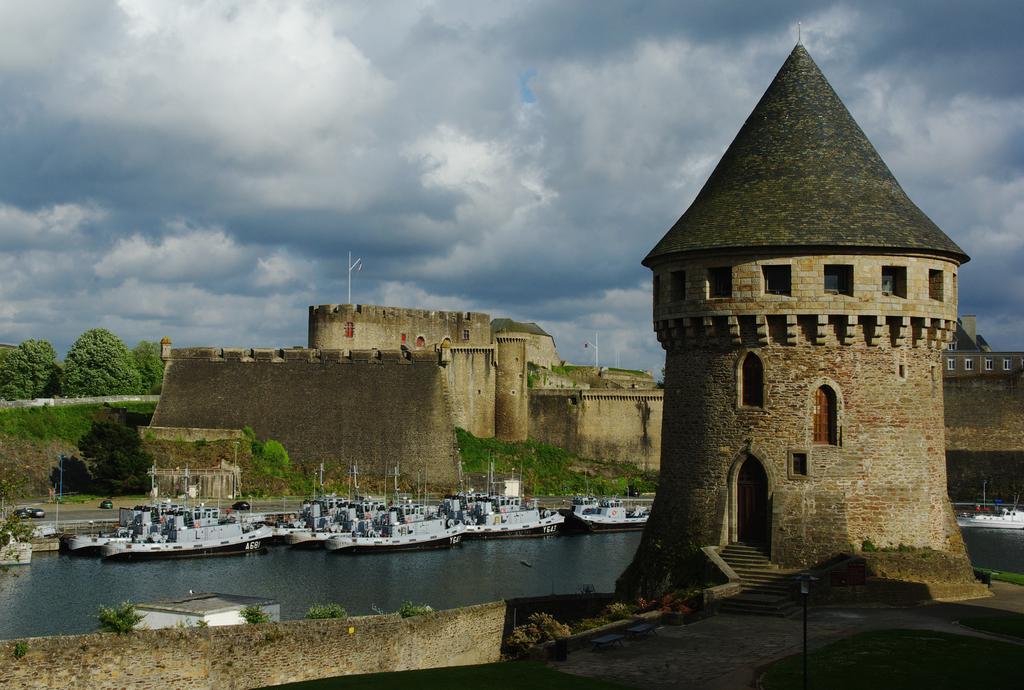Could you give a brief overview of what you see in this image? In this image, there is an outside view. In the foreground, there are some boats floating on the water. There is a fort in the middle of the image. There are some trees on the left side of the image. There is a sky in the background of the image. 